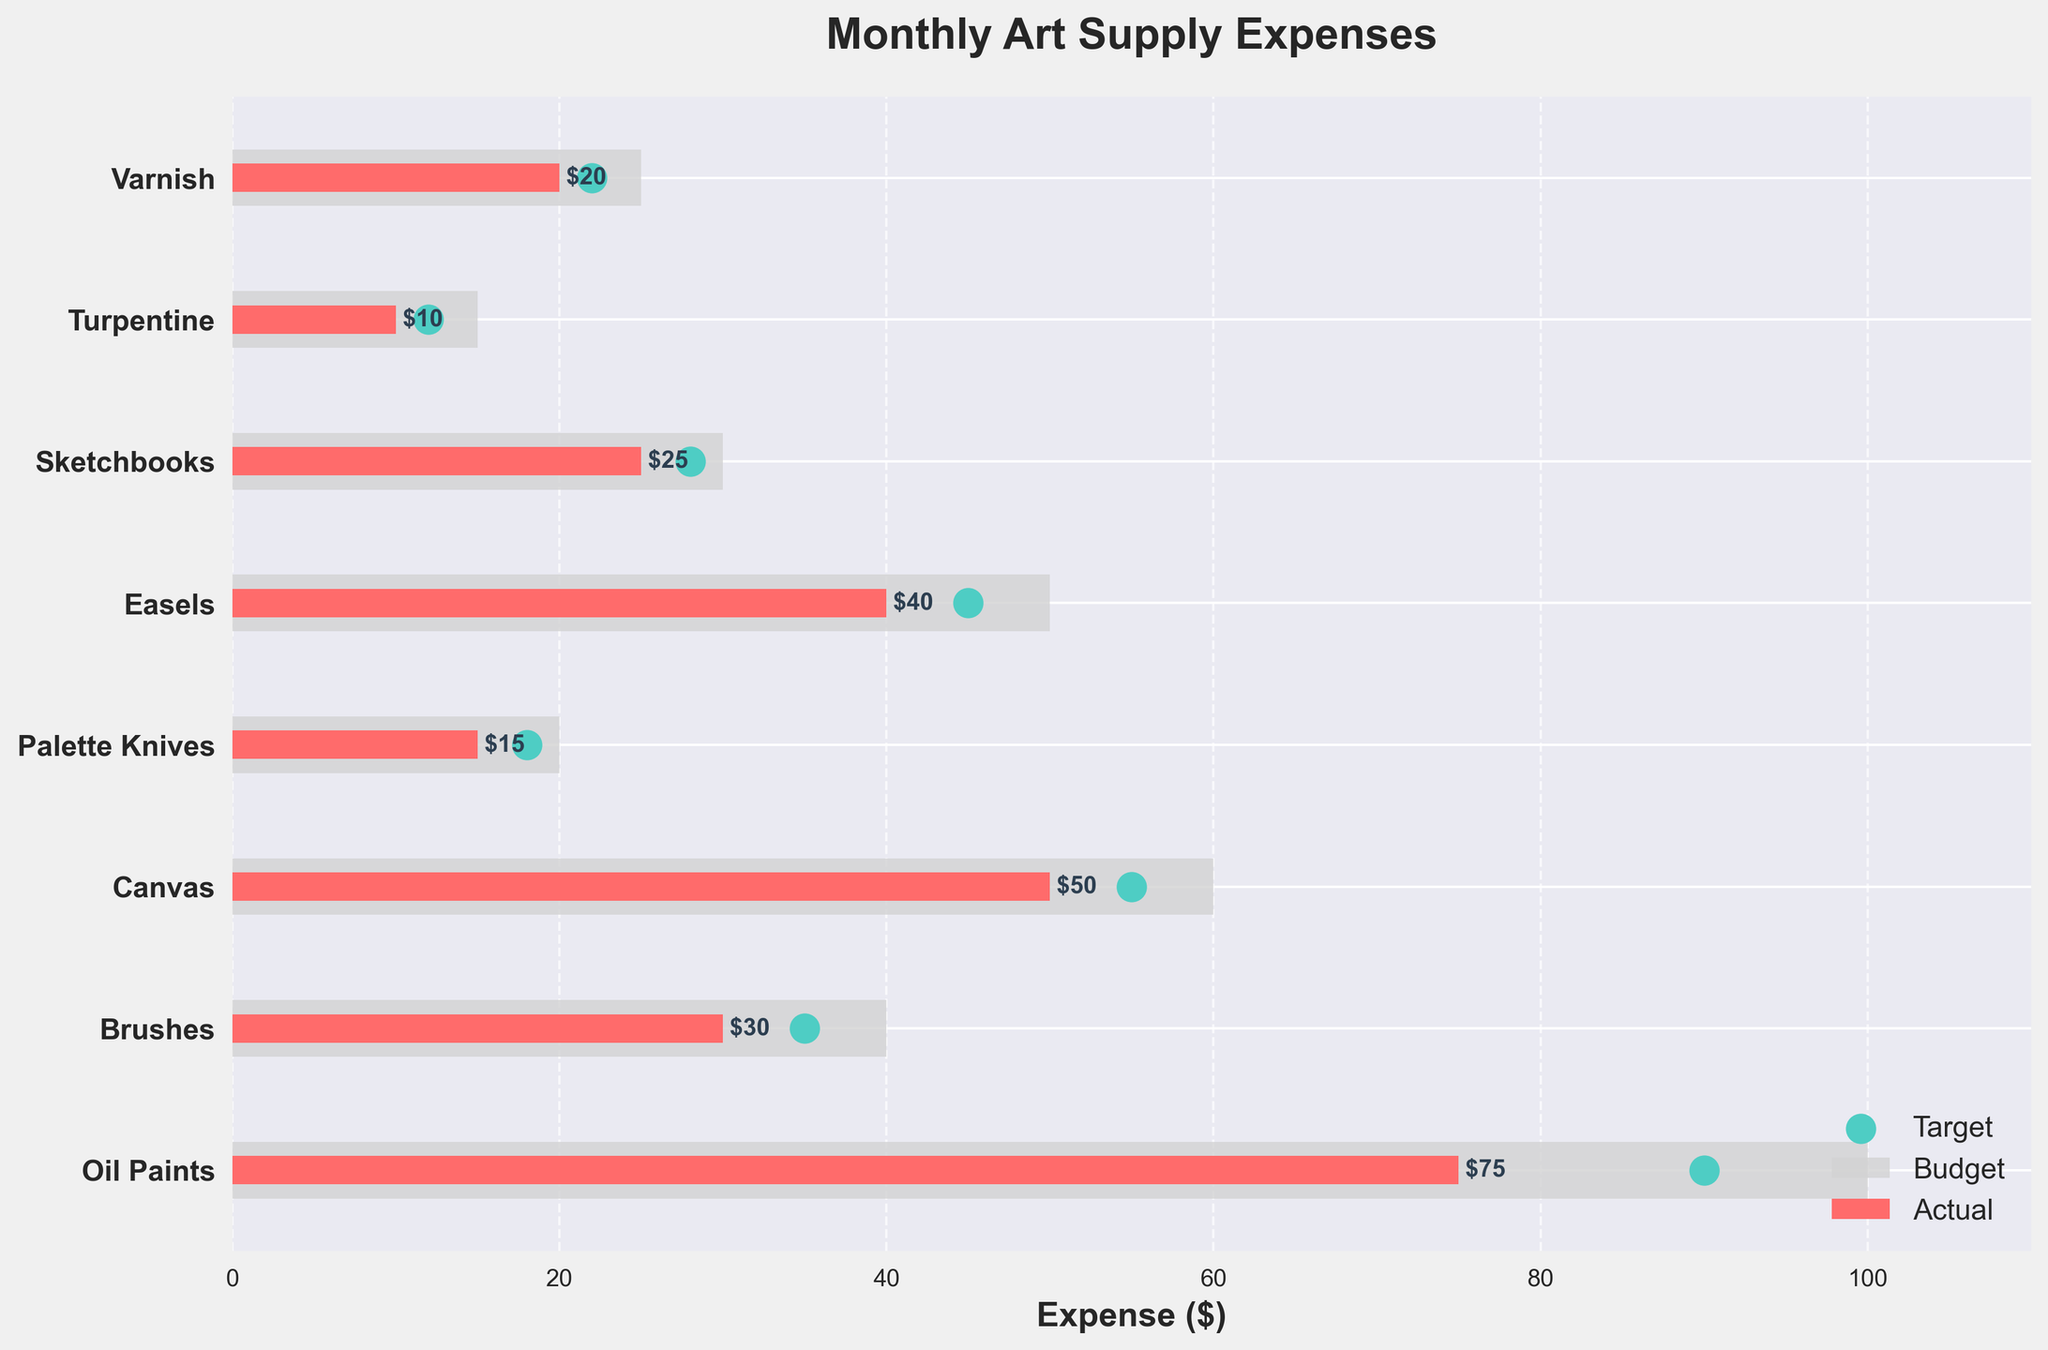what's the title of the figure? The title is displayed at the top of the figure indicating what the plot represents. The title of the figure is "Monthly Art Supply Expenses".
Answer: Monthly Art Supply Expenses what is the maximum value on the x-axis? The maximum value on the x-axis can be identified by the highest tick mark. The evaluation of the range shows that it extends up to 110 to accommodate the highest budget with margins.
Answer: 110 which category has the highest actual expense? Observe the length of the actual expense bars and compare them. The category with the longest actual expense bar is "Oil Paints".
Answer: Oil Paints Did "Brushes" meet its target expense? Check if the actual expense bar for "Brushes" reaches the target marker (green dot). Since the actual expense bar is less than the target for "Brushes", it did not meet its target expense.
Answer: No what's the average budgeted amount across all categories? To find the average, sum up all the budget values (100 + 40 + 60 + 20 + 50 + 30 + 15 + 25 = 340) and divide by the number of categories (8).
Answer: 340/8 = 42.5 which category has the smallest difference between actual expense and budget? Subtract the actual expense from the budget for each category and identify the smallest difference. Differences are: Oil Paints (25), Brushes (10), Canvas (10), Palette Knives (5), Easels (10), Sketchbooks (5), Turpentine (5), Varnish (5). The smallest difference is 5 seen in "Palette Knives", "Sketchbooks", "Turpentine", and "Varnish".
Answer: Palette Knives, Sketchbooks, Turpentine, Varnish are there any categories where the actual expense is higher than the budget? Compare the lengths of the actual expense bars to their corresponding budgets. None of the actual expense bars exceed their budgeted amounts.
Answer: No what's the total actual expense for all categories? Sum up the actual expenses of all categories (75 + 30 + 50 + 15 + 40 + 25 + 10 + 20 = 265).
Answer: 265 how many categories are plotted in the figure? Count the number of horizontal bars or listed categories on the y-axis. There are 8 categories shown.
Answer: 8 